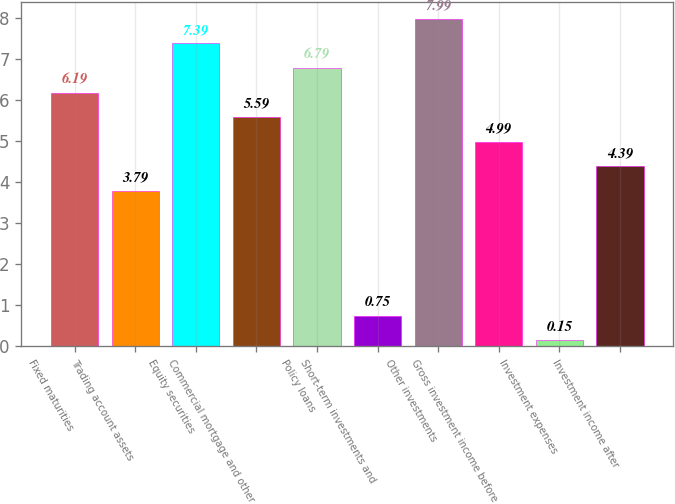Convert chart. <chart><loc_0><loc_0><loc_500><loc_500><bar_chart><fcel>Fixed maturities<fcel>Trading account assets<fcel>Equity securities<fcel>Commercial mortgage and other<fcel>Policy loans<fcel>Short-term investments and<fcel>Other investments<fcel>Gross investment income before<fcel>Investment expenses<fcel>Investment income after<nl><fcel>6.19<fcel>3.79<fcel>7.39<fcel>5.59<fcel>6.79<fcel>0.75<fcel>7.99<fcel>4.99<fcel>0.15<fcel>4.39<nl></chart> 